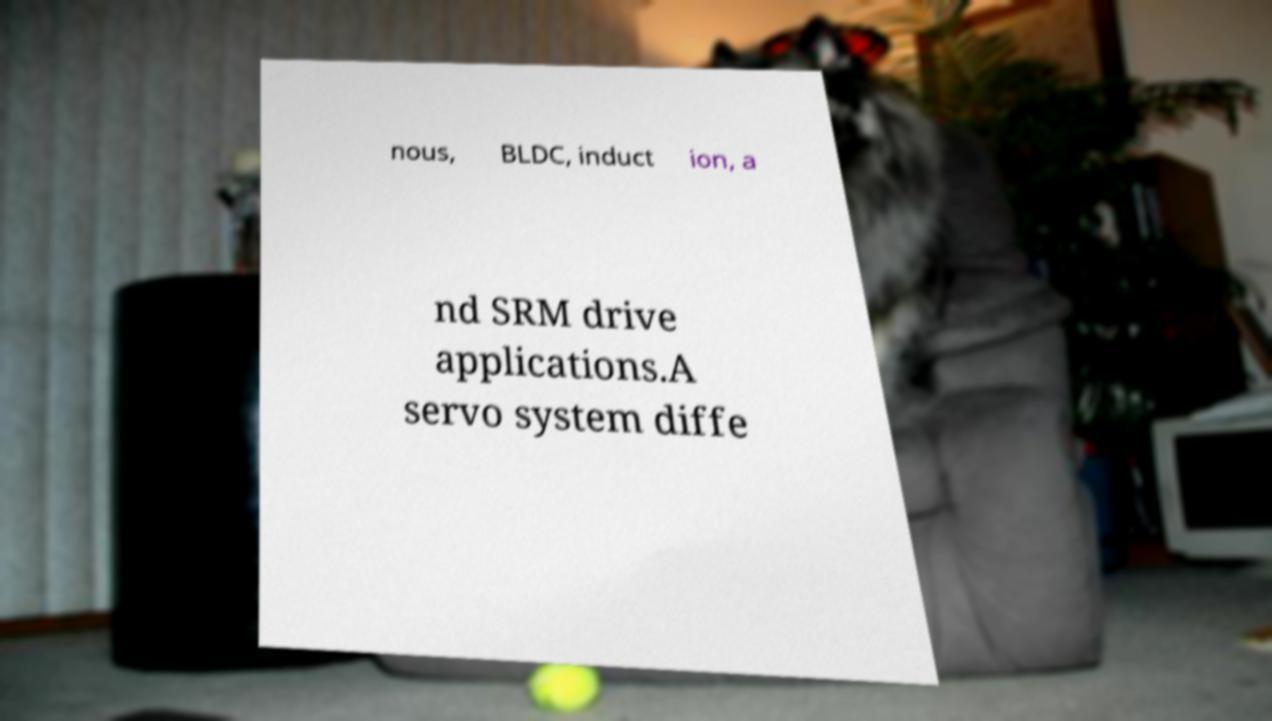I need the written content from this picture converted into text. Can you do that? nous, BLDC, induct ion, a nd SRM drive applications.A servo system diffe 